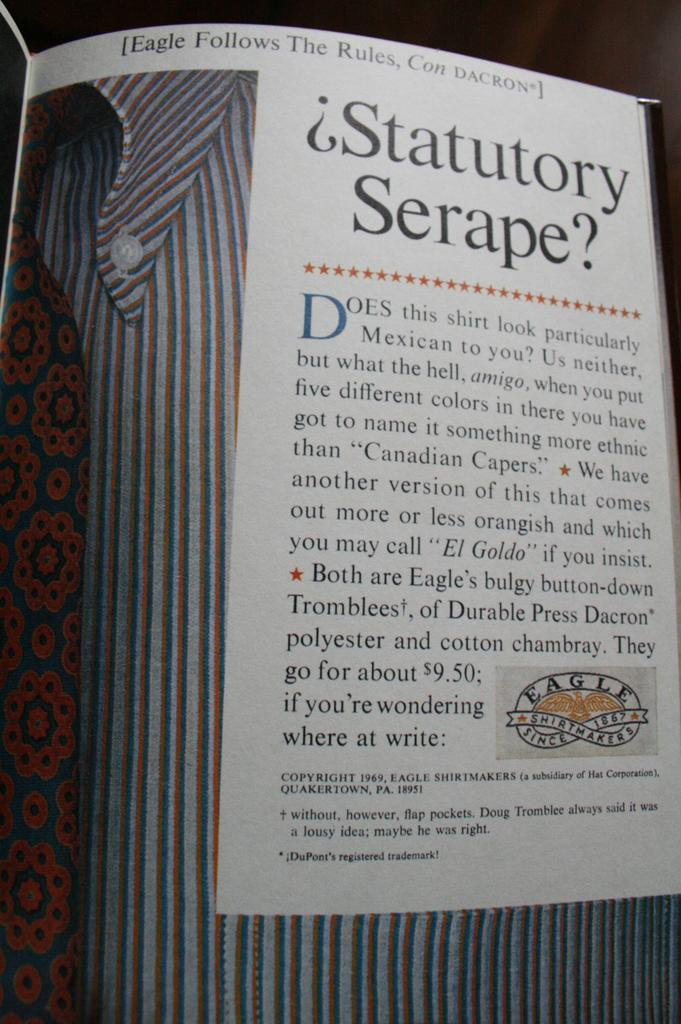<image>
Write a terse but informative summary of the picture. the word statutory that is on a paper 